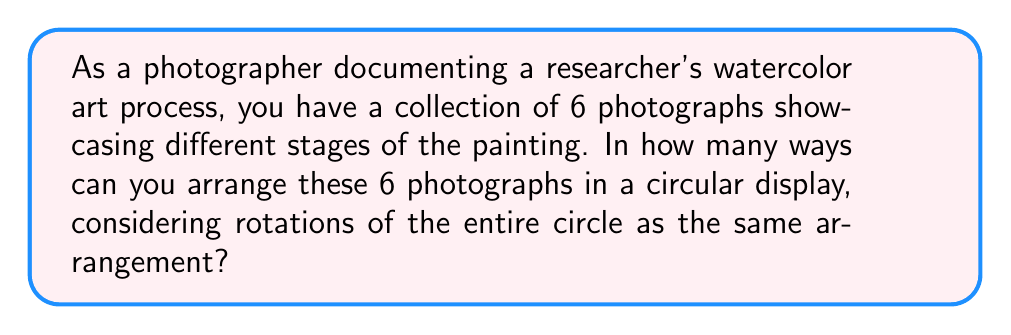Show me your answer to this math problem. To solve this problem, we need to consider the properties of permutation groups, specifically cyclic permutations.

1. First, let's consider the total number of ways to arrange 6 photographs in a line. This would be a straightforward permutation:
   $6! = 6 \times 5 \times 4 \times 3 \times 2 \times 1 = 720$

2. However, in a circular arrangement, rotations of the entire circle are considered the same arrangement. This means that for each unique circular arrangement, there are 6 linear arrangements that are equivalent (as we can start from any of the 6 positions).

3. To account for this, we need to divide the total number of linear arrangements by the number of positions in the circle:

   $$\text{Number of circular arrangements} = \frac{\text{Number of linear arrangements}}{\text{Number of positions}} = \frac{6!}{6}$$

4. Simplifying this expression:
   $$\frac{6!}{6} = \frac{720}{6} = 120$$

Therefore, there are 120 unique ways to arrange the 6 photographs in a circular display.

This result is an application of the orbit-stabilizer theorem in group theory, where we are essentially finding the number of orbits under the action of the cyclic group $C_6$ on the set of all permutations of 6 elements.
Answer: 120 unique circular arrangements 